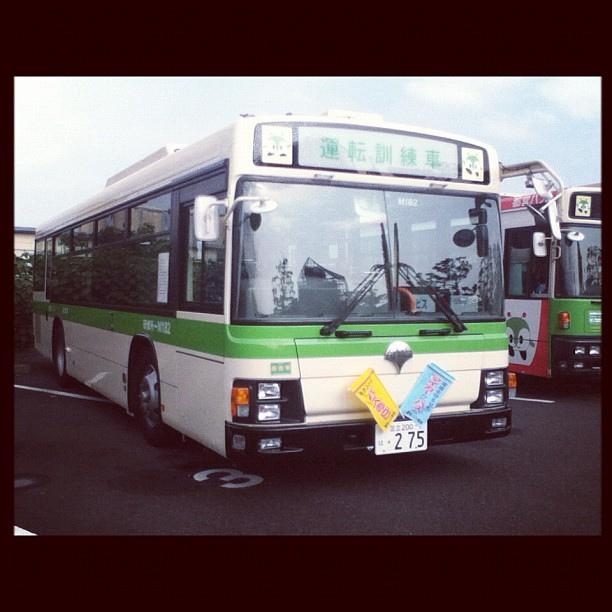What side of the road does this bus drive on?
Short answer required. Left. Does the street surface looked newly paved?
Concise answer only. Yes. What color is the bus?
Short answer required. White. Is there an American license plate on the black car?
Write a very short answer. No. What color is this bus?
Quick response, please. Green and white. Is the bus parked well?
Write a very short answer. No. What bus station is this?
Give a very brief answer. China. What is the route listed on the front of the bus?
Answer briefly. China. 